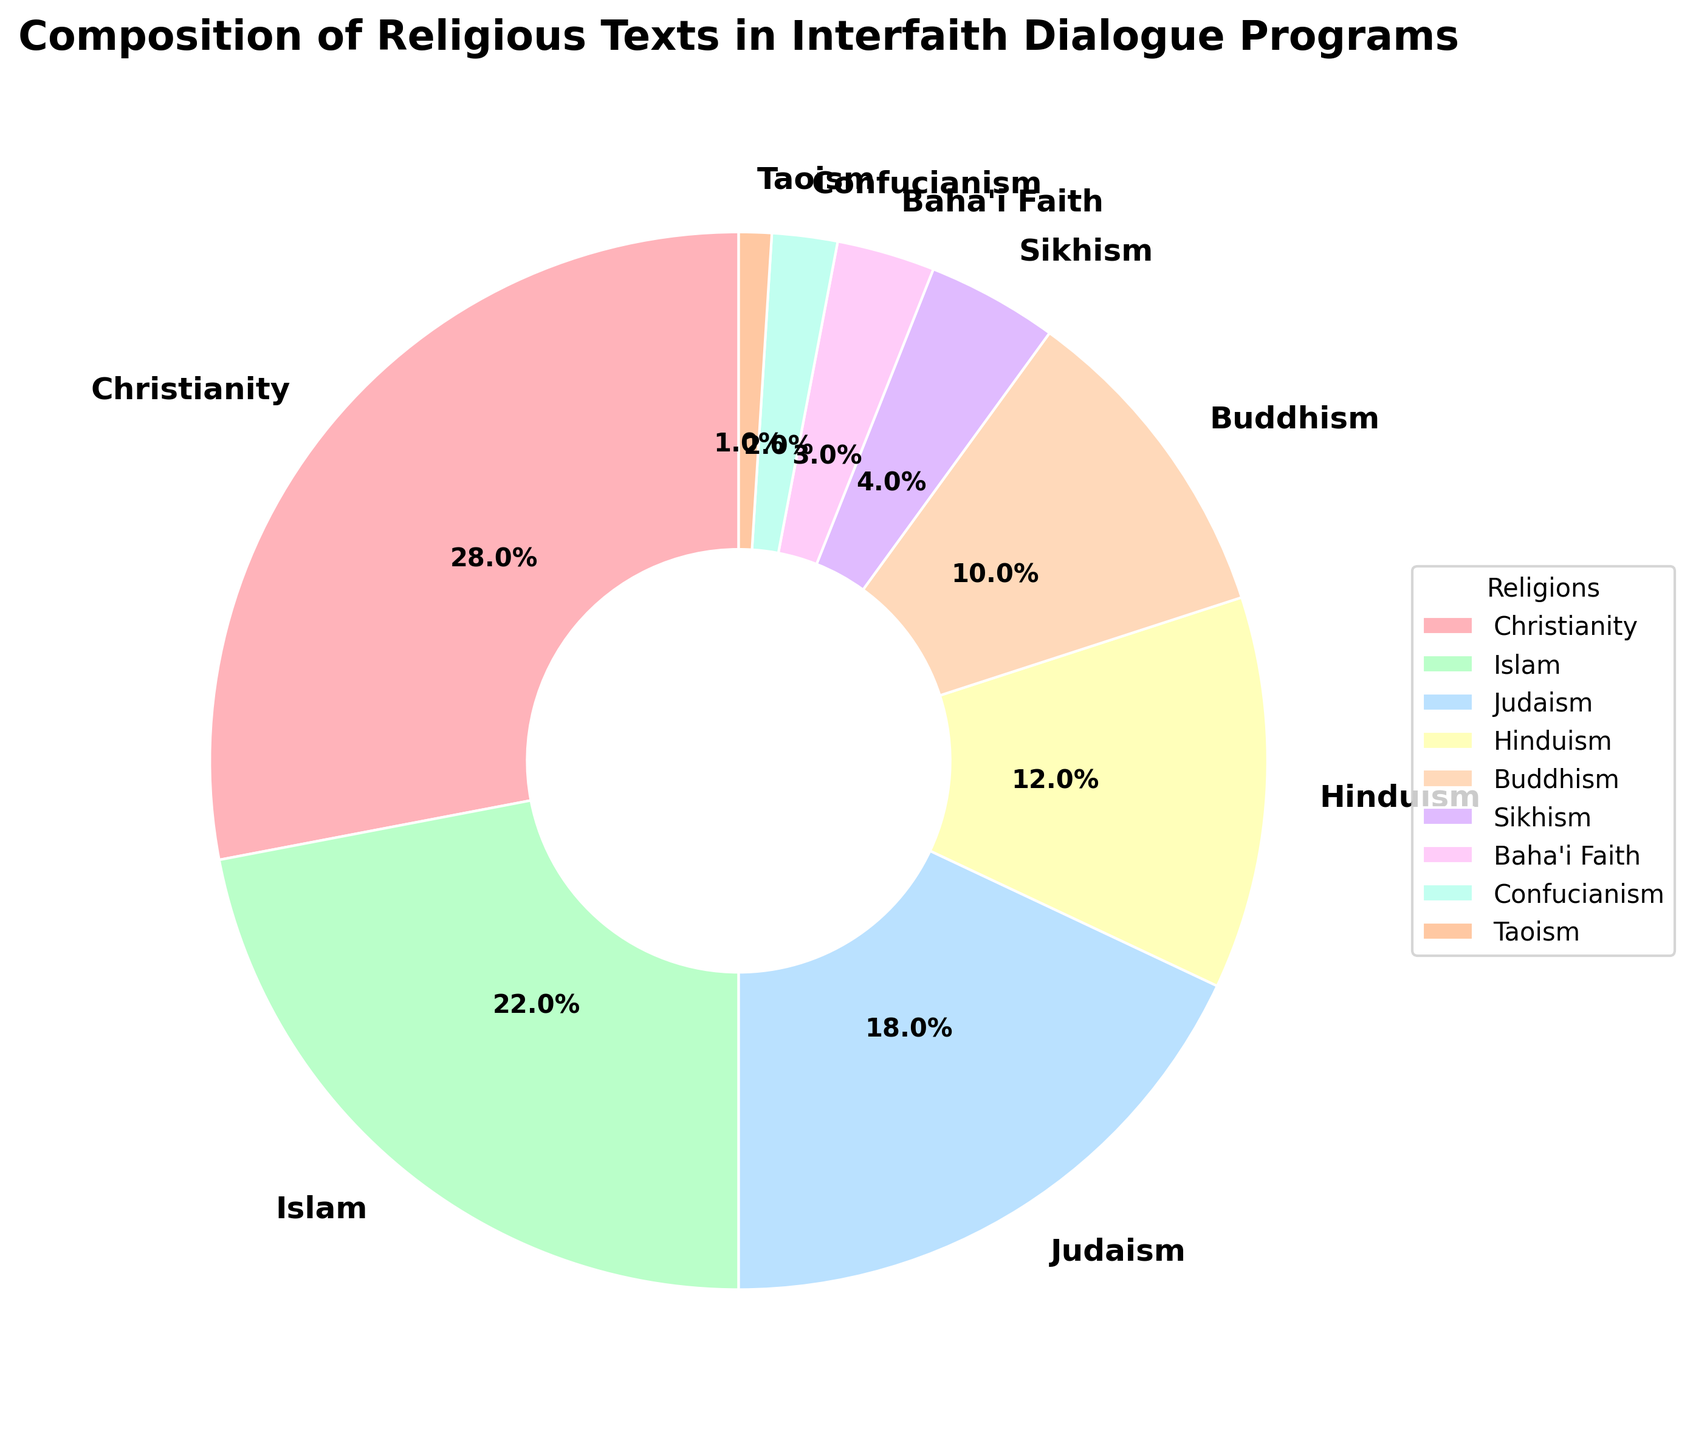Which religion's texts are studied the most in interfaith dialogue programs? The largest section of the pie chart, representing 28%, is labeled as Christianity.
Answer: Christianity Which two religions together make up 40% of the studied texts? The texts from Islam (22%) and Judaism (18%) together add up to 40%.
Answer: Islam and Judaism How much more are Christian texts studied compared to Hindu texts? Christianity texts are 28% and Hinduism texts are 12%. The difference is 28% - 12% = 16%.
Answer: 16% Are Buddhist and Sikh texts together studied more or less than Hindu texts? Buddhist texts are 10% and Sikh texts are 4%. Together, they add up to 10% + 4% = 14%, which is more than Hindu texts at 12%.
Answer: More What is the combined percentage of texts studied that originate from the Baha'i Faith, Confucianism, and Taoism? Baha'i Faith texts are 3%, Confucianism texts are 2%, and Taoism texts are 1%. Combined, they make up 3% + 2% + 1% = 6%.
Answer: 6% Which religion's texts form the smallest proportion of the studied material? The smallest section of the pie chart, representing 1%, is labeled as Taoism.
Answer: Taoism How does the percentage of texts studied from Islam compare to those from Buddhism? Islamic texts make up 22% while Buddhist texts make up 10%. Islamic texts are studied more than Buddhist texts by 22% - 10% = 12%.
Answer: Islam is 12% more Which three largest segments together make up more than half of the studied texts? The three largest segments are Christianity (28%), Islam (22%), and Judaism (18%). Together, they total 28% + 22% + 18% = 68%, which is more than half.
Answer: Christianity, Islam, and Judaism How many religions's texts make up less than 5% of the studied texts each? The segments for Sikhism (4%), Baha'i Faith (3%), Confucianism (2%), and Taoism (1%) each are less than 5%. There are four such religions.
Answer: 4 Are texts originating from Buddhism studied equally as much as texts from Hinduism and Sikhism combined? Buddhism texts are 10%. Hinduism texts are 12% and Sikhism texts are 4%. Combined, Hinduism and Sikhism make up 12% + 4% = 16%, which is more than Buddhist texts' 10%.
Answer: No 